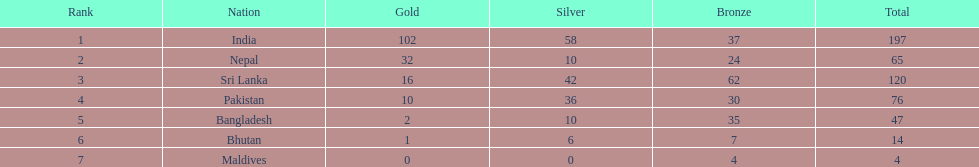What is the difference in total number of medals between india and nepal? 132. 